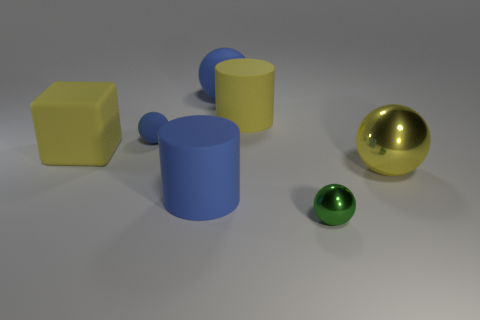Subtract all big metal spheres. How many spheres are left? 3 Subtract all green balls. How many balls are left? 3 Subtract 1 balls. How many balls are left? 3 Add 2 cylinders. How many objects exist? 9 Subtract all cubes. How many objects are left? 6 Subtract all cyan cubes. How many brown balls are left? 0 Subtract all large blue things. Subtract all large blue matte cylinders. How many objects are left? 4 Add 1 yellow shiny spheres. How many yellow shiny spheres are left? 2 Add 4 big yellow objects. How many big yellow objects exist? 7 Subtract 0 red spheres. How many objects are left? 7 